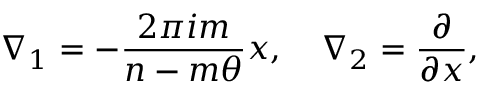<formula> <loc_0><loc_0><loc_500><loc_500>\nabla _ { 1 } = - \frac { 2 \pi i m } { n - m \theta } x , \quad \nabla _ { 2 } = \frac { \partial } { \partial x } ,</formula> 